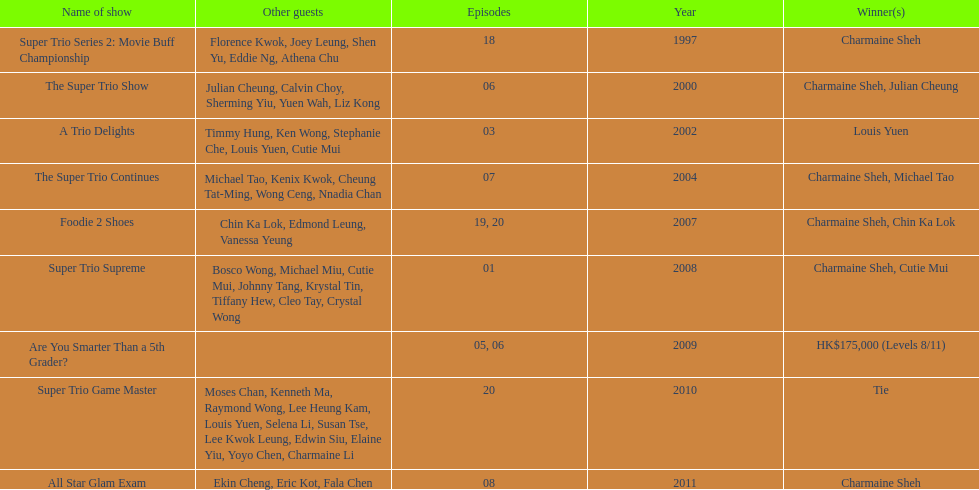What is the number of tv shows that charmaine sheh has appeared on? 9. 